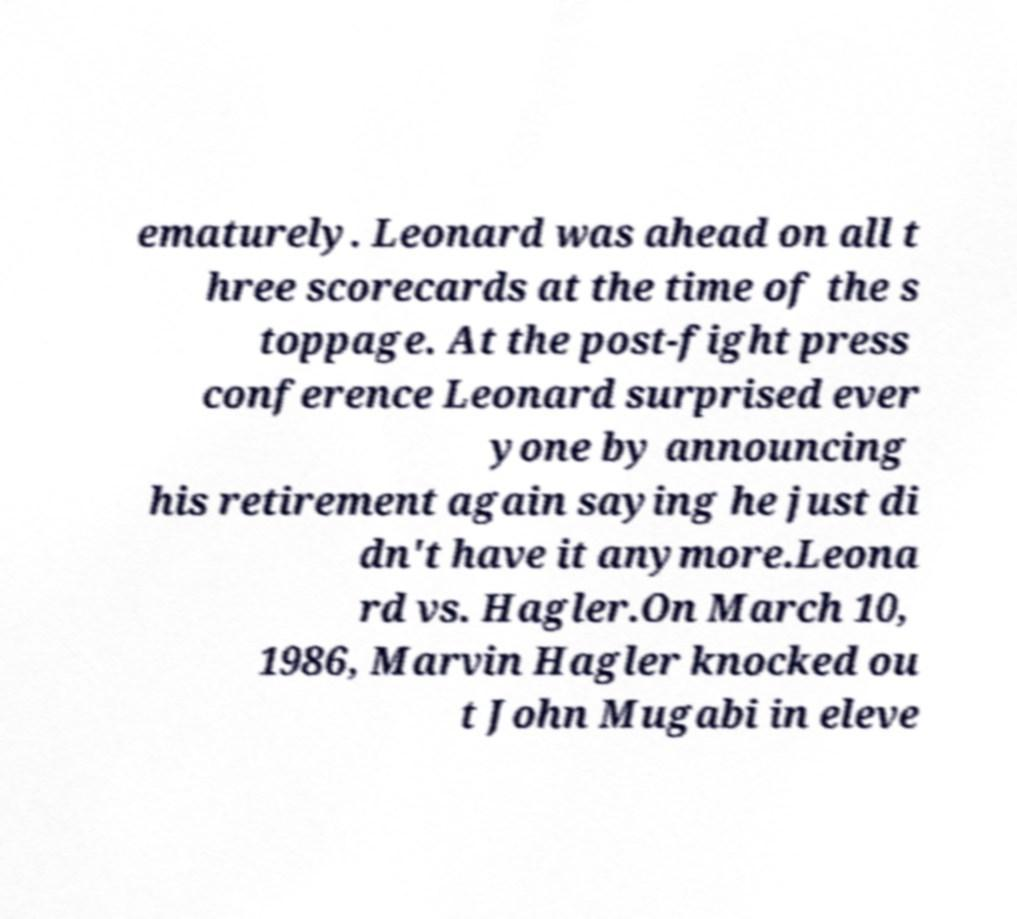I need the written content from this picture converted into text. Can you do that? ematurely. Leonard was ahead on all t hree scorecards at the time of the s toppage. At the post-fight press conference Leonard surprised ever yone by announcing his retirement again saying he just di dn't have it anymore.Leona rd vs. Hagler.On March 10, 1986, Marvin Hagler knocked ou t John Mugabi in eleve 